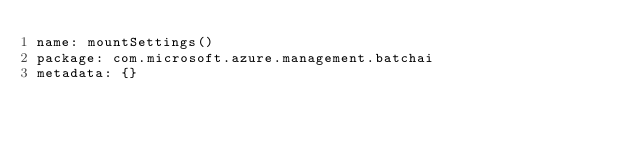Convert code to text. <code><loc_0><loc_0><loc_500><loc_500><_YAML_>name: mountSettings()
package: com.microsoft.azure.management.batchai
metadata: {}
</code> 